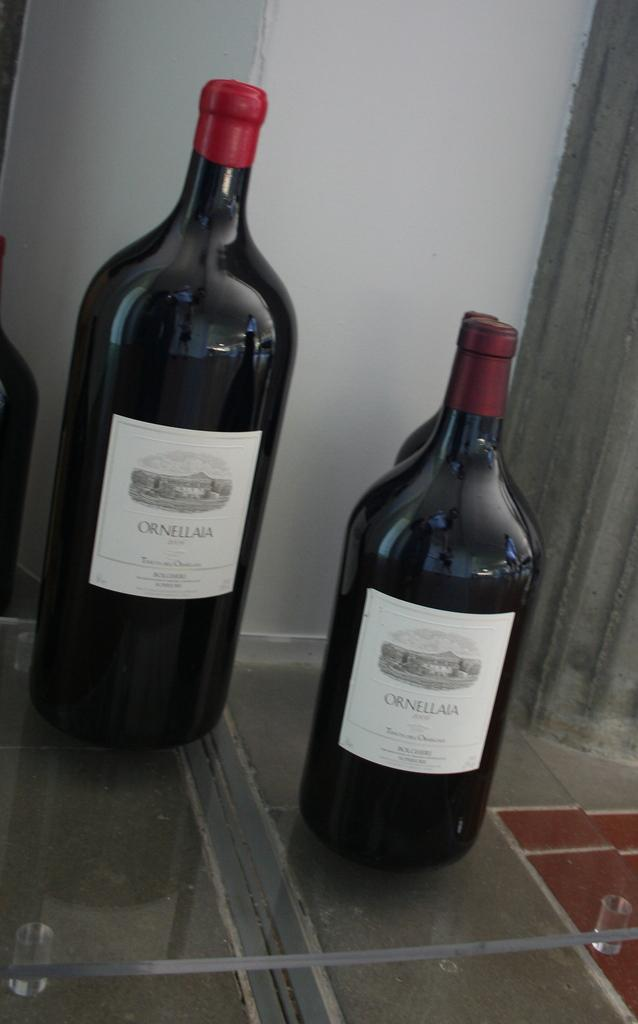<image>
Offer a succinct explanation of the picture presented. Two wine bottles from Ornellaia on the counter 